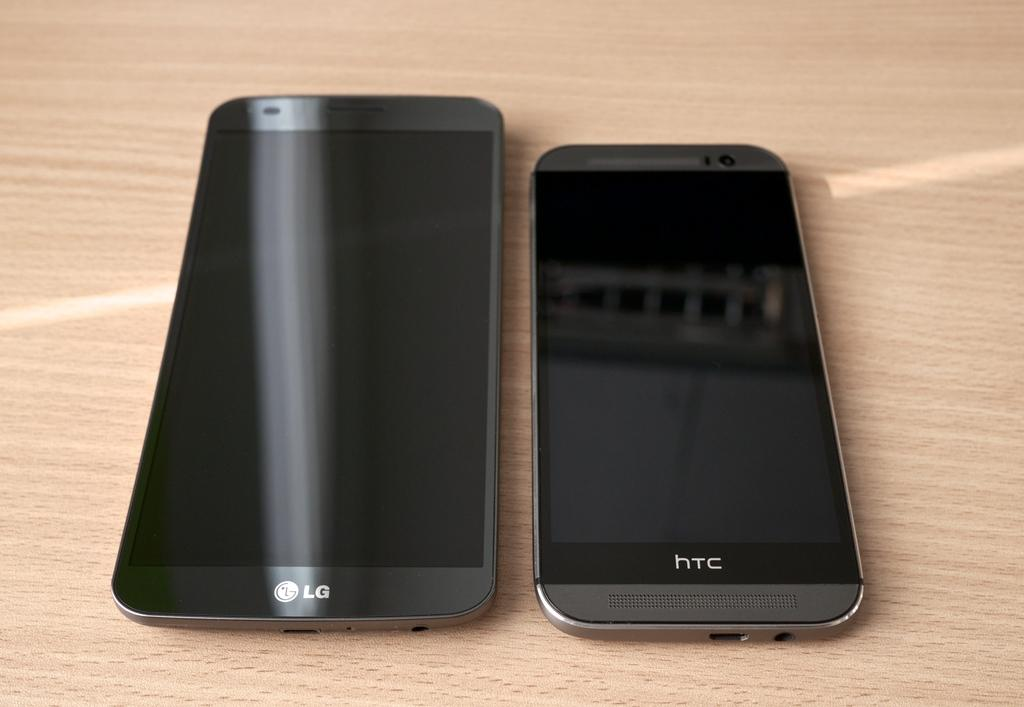<image>
Relay a brief, clear account of the picture shown. Two phones side by side with one phone saying HTC. 